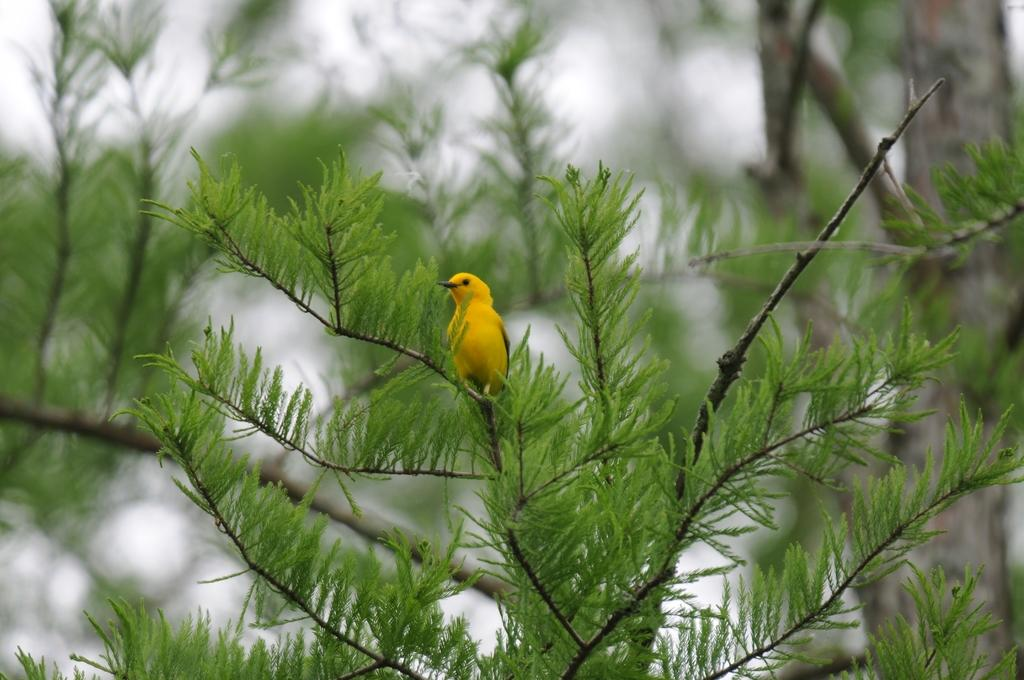What type of animal can be seen in the image? There is a bird in the image. Where is the bird located? The bird is on a tree. Can you describe the background of the image? The background of the image is blurred. What type of cakes can be seen in the image? There are no cakes present in the image; it features a bird on a tree with a blurred background. 